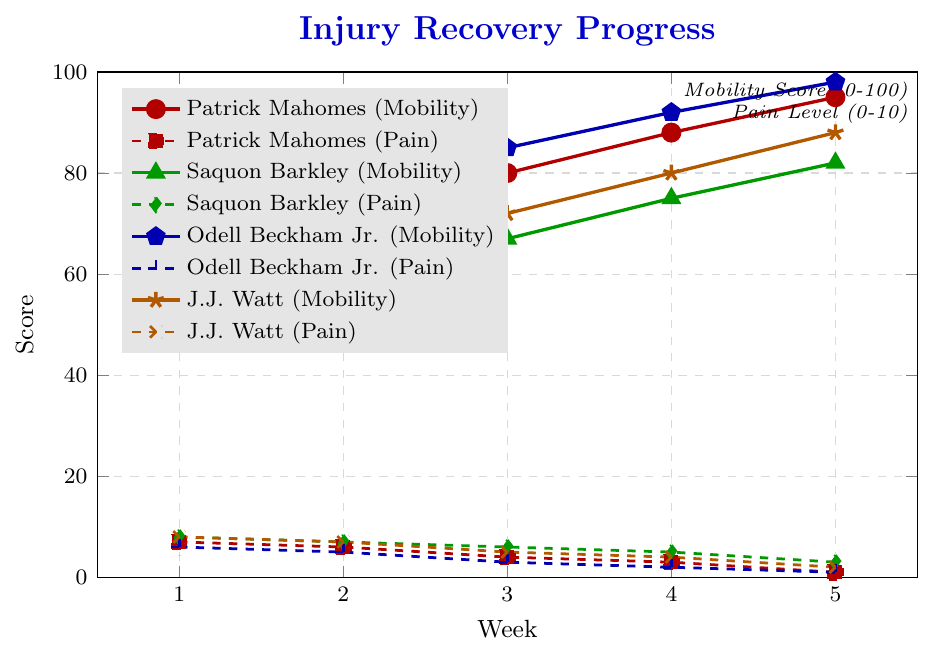What's the overall trend in Patrick Mahomes' mobility score over the 5 weeks? The mobility score for Patrick Mahomes increases from 65 in week 1 to 95 in week 5, showing a consistent upward trend.
Answer: Increases Which player's pain level dropped the most from week 1 to week 5? Comparing the drops in pain levels from week 1 to week 5: Patrick Mahomes (7 to 1 = 6), Saquon Barkley (8 to 3 = 5), Odell Beckham Jr. (6 to 1 = 5), and J.J. Watt (8 to 2 = 6). Both Patrick Mahomes and J.J. Watt have the largest drop of 6.
Answer: Patrick Mahomes and J.J. Watt Between Saquon Barkley and Odell Beckham Jr., whose pain level decreased faster over the first three weeks? Saquon Barkley's pain level dropped from 8 to 6 in three weeks (a decrease of 2), while Odell Beckham Jr.'s pain level dropped from 6 to 3 in the same period (a decrease of 3). Therefore, Odell Beckham Jr.'s pain level decreased faster.
Answer: Odell Beckham Jr Which player had the highest mobility score in week 5? In week 5, the mobility scores are: Patrick Mahomes (95), Saquon Barkley (82), Odell Beckham Jr. (98), and J.J. Watt (88). Odell Beckham Jr. has the highest mobility score in week 5 with 98.
Answer: Odell Beckham Jr How do the mobility scores of Saquon Barkley and J.J. Watt compare in week 2? In week 2, the mobility scores are: Saquon Barkley (58) and J.J. Watt (63). J.J. Watt's mobility score is higher than Saquon Barkley's by 5 points.
Answer: J.J. Watt's is higher by 5 What's the average mobility score of Odell Beckham Jr. over the 5 weeks? Adding the mobility scores for Odell Beckham Jr. over 5 weeks: (70 + 78 + 85 + 92 + 98) = 423. The average is 423/5 = 84.6
Answer: 84.6 By how much did J.J. Watt's pain level decrease from week 3 to week 5? J.J. Watt's pain level in week 3 is 5, and in week 5 it is 2. The decrease in pain level is 5 - 2 = 3.
Answer: 3 Compare the mobility scores of Patrick Mahomes and Odell Beckham Jr. in week 3. Who had a higher score and by how much? In week 3, Patrick Mahomes has a mobility score of 80 and Odell Beckham Jr. has a score of 85. Odell Beckham Jr. has a higher score by 5 points.
Answer: Odell Beckham Jr. by 5 